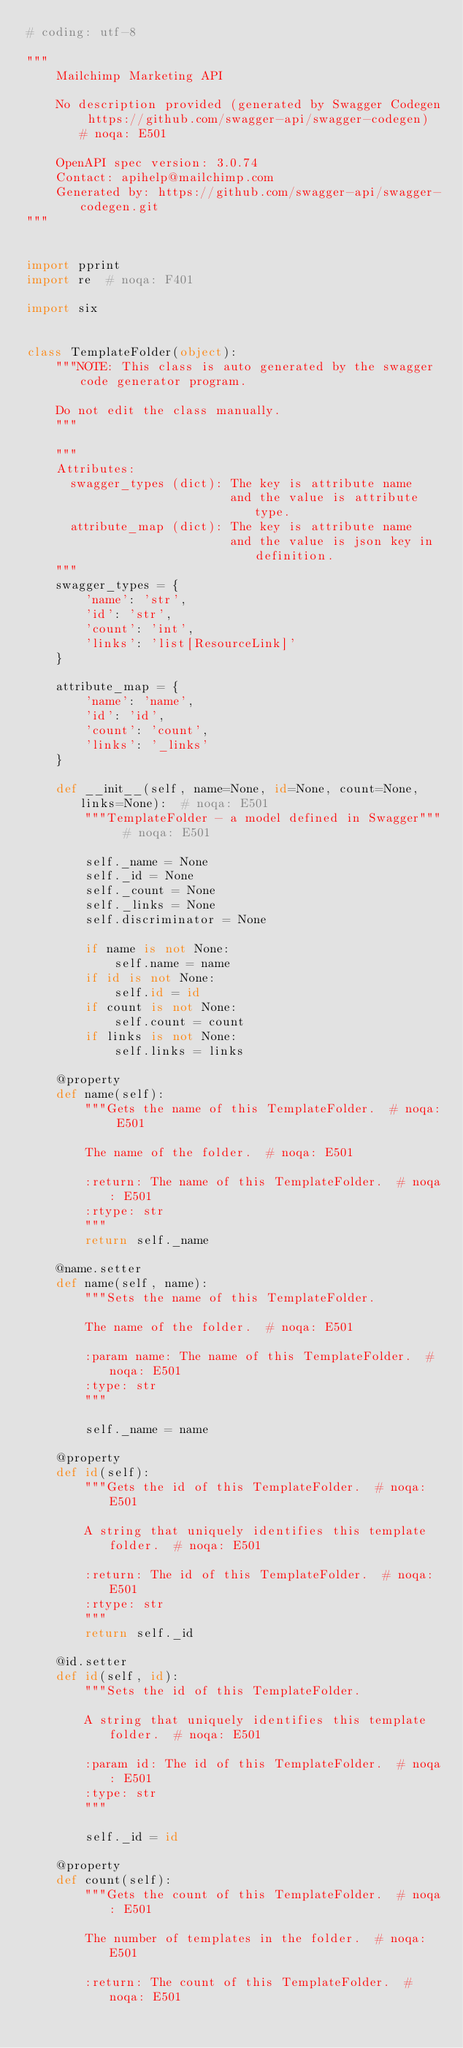Convert code to text. <code><loc_0><loc_0><loc_500><loc_500><_Python_># coding: utf-8

"""
    Mailchimp Marketing API

    No description provided (generated by Swagger Codegen https://github.com/swagger-api/swagger-codegen)  # noqa: E501

    OpenAPI spec version: 3.0.74
    Contact: apihelp@mailchimp.com
    Generated by: https://github.com/swagger-api/swagger-codegen.git
"""


import pprint
import re  # noqa: F401

import six


class TemplateFolder(object):
    """NOTE: This class is auto generated by the swagger code generator program.

    Do not edit the class manually.
    """

    """
    Attributes:
      swagger_types (dict): The key is attribute name
                            and the value is attribute type.
      attribute_map (dict): The key is attribute name
                            and the value is json key in definition.
    """
    swagger_types = {
        'name': 'str',
        'id': 'str',
        'count': 'int',
        'links': 'list[ResourceLink]'
    }

    attribute_map = {
        'name': 'name',
        'id': 'id',
        'count': 'count',
        'links': '_links'
    }

    def __init__(self, name=None, id=None, count=None, links=None):  # noqa: E501
        """TemplateFolder - a model defined in Swagger"""  # noqa: E501

        self._name = None
        self._id = None
        self._count = None
        self._links = None
        self.discriminator = None

        if name is not None:
            self.name = name
        if id is not None:
            self.id = id
        if count is not None:
            self.count = count
        if links is not None:
            self.links = links

    @property
    def name(self):
        """Gets the name of this TemplateFolder.  # noqa: E501

        The name of the folder.  # noqa: E501

        :return: The name of this TemplateFolder.  # noqa: E501
        :rtype: str
        """
        return self._name

    @name.setter
    def name(self, name):
        """Sets the name of this TemplateFolder.

        The name of the folder.  # noqa: E501

        :param name: The name of this TemplateFolder.  # noqa: E501
        :type: str
        """

        self._name = name

    @property
    def id(self):
        """Gets the id of this TemplateFolder.  # noqa: E501

        A string that uniquely identifies this template folder.  # noqa: E501

        :return: The id of this TemplateFolder.  # noqa: E501
        :rtype: str
        """
        return self._id

    @id.setter
    def id(self, id):
        """Sets the id of this TemplateFolder.

        A string that uniquely identifies this template folder.  # noqa: E501

        :param id: The id of this TemplateFolder.  # noqa: E501
        :type: str
        """

        self._id = id

    @property
    def count(self):
        """Gets the count of this TemplateFolder.  # noqa: E501

        The number of templates in the folder.  # noqa: E501

        :return: The count of this TemplateFolder.  # noqa: E501</code> 